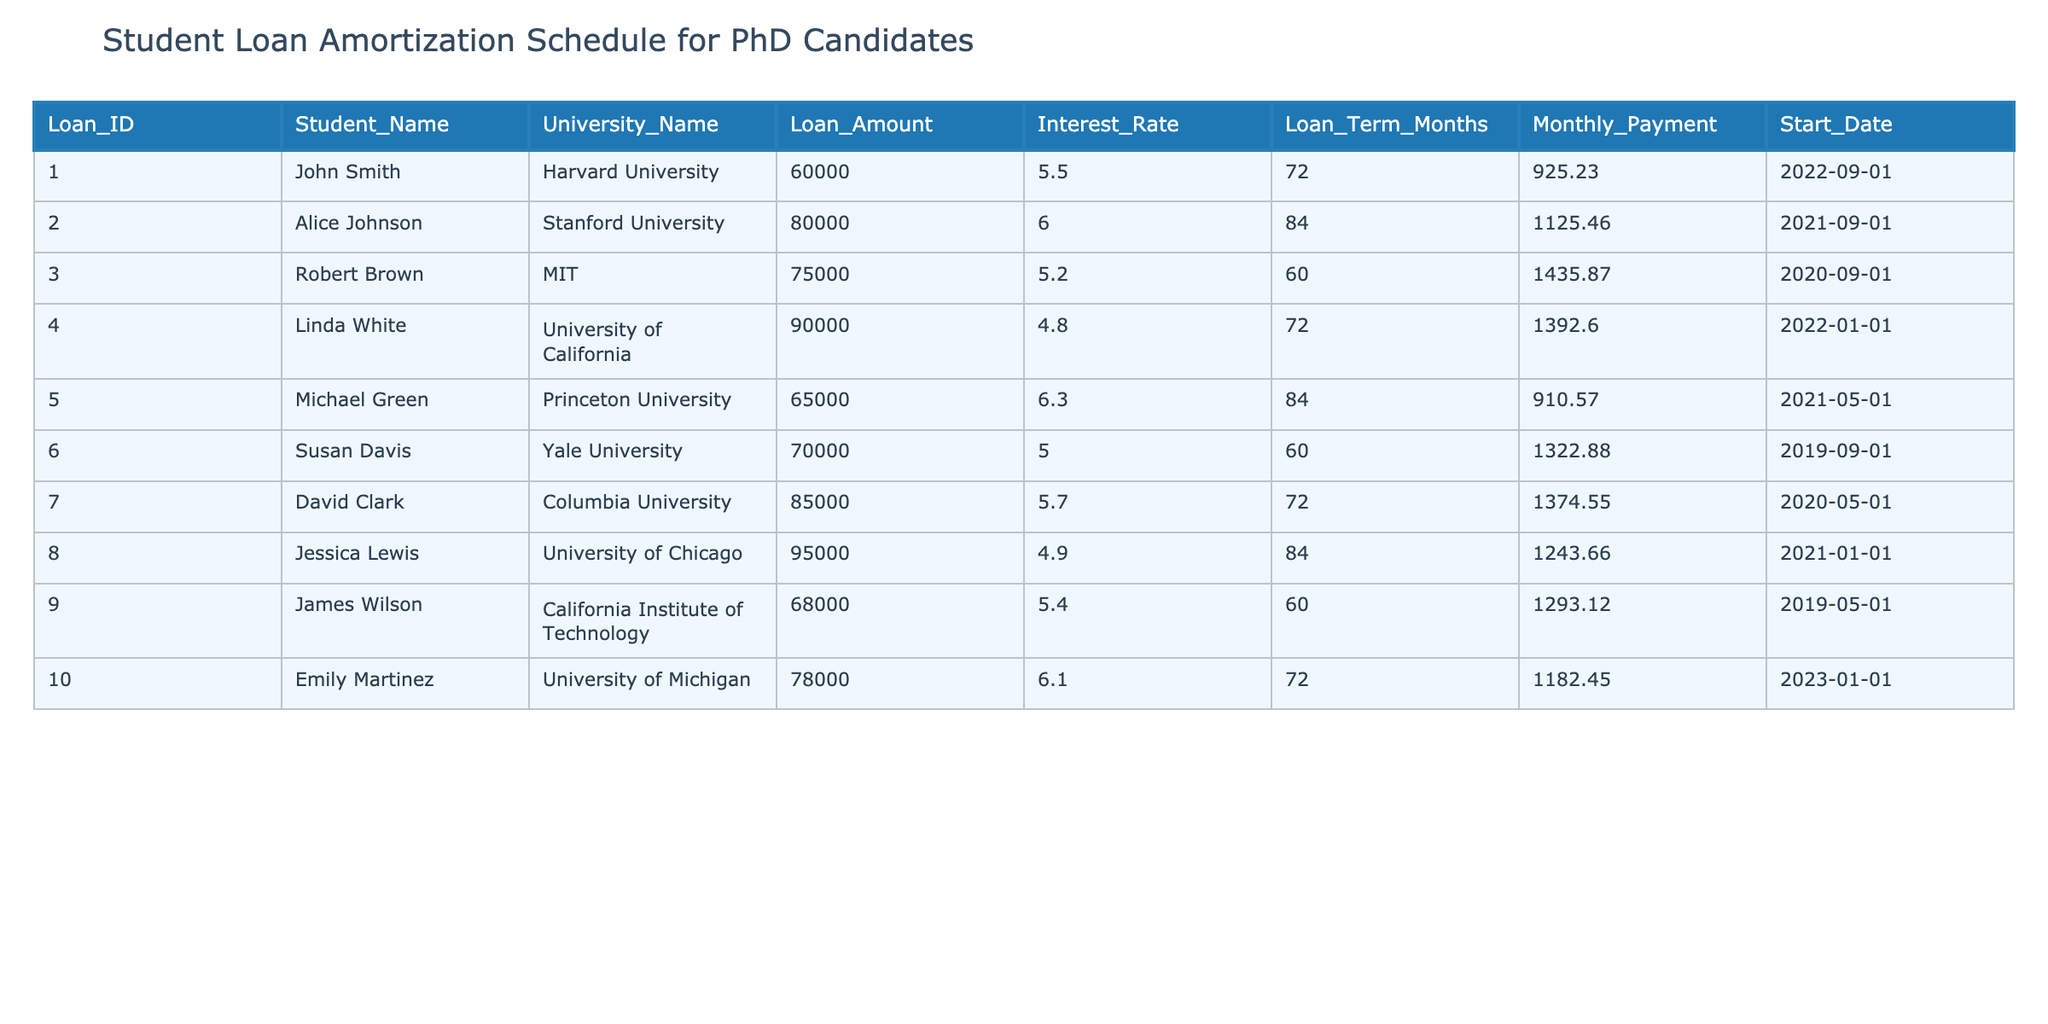What is the loan amount taken by Alice Johnson? Referring to the table, the loan amount for Alice Johnson, who is attending Stanford University, is clearly stated in the "Loan_Amount" column. It shows that the amount is 80000.
Answer: 80000 Which university has the highest loan amount requested? Looking across the "University_Name" and "Loan_Amount" columns, the maximum loan amount of 95000 corresponds to the University of Chicago.
Answer: University of Chicago What is the average interest rate of the loans in this table? To find the average interest rate, we sum all the interest rates from the "Interest_Rate" column: (5.5 + 6.0 + 5.2 + 4.8 + 6.3 + 5.0 + 5.7 + 4.9 + 5.4 + 6.1) = 57.0. There are 10 loans, so the average is 57.0 / 10 = 5.7.
Answer: 5.7 Is Linda White taking a loan for more than 70 months? By checking the "Loan_Term_Months" column for Linda White, we see that the term is 72 months, which is indeed more than 70 months.
Answer: Yes What is the total monthly payment for all loans combined? To find the total monthly payment, we sum all the values in the "Monthly_Payment" column: (925.23 + 1125.46 + 1435.87 + 1392.60 + 910.57 + 1322.88 + 1374.55 + 1243.66 + 1293.12 + 1182.45) = 13918.56. Therefore, the total monthly payment is 13918.56.
Answer: 13918.56 Which student has the lowest monthly payment? Inspecting the "Monthly_Payment" column, we find that Michael Green pays the least amount, which is 910.57.
Answer: Michael Green How many loans are longer than 60 months? By reviewing the "Loan_Term_Months" column, we identify loans that exceed 60 months: Loans for Alice Johnson, Robert Brown, Linda White, Michael Green, David Clark, and Jessica Lewis, totaling 6 loans. Thus, the number of loans longer than 60 months is 6.
Answer: 6 Does James Wilson have a loan with a lower interest rate than 5.5%? Reviewing the "Interest_Rate" column for James Wilson, his rate is 5.4%, which is indeed lower than 5.5%.
Answer: Yes What is the difference in loan amounts between the highest and lowest loan amounts? The highest loan amount is 95000 for Jessica Lewis, and the lowest is 60000 for John Smith. The difference is calculated as 95000 - 60000 = 35000.
Answer: 35000 